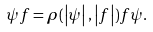<formula> <loc_0><loc_0><loc_500><loc_500>\psi f = \rho ( \left | \psi \right | , \left | f \right | ) f \psi .</formula> 